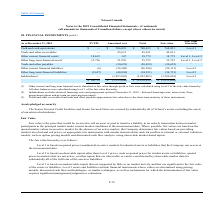From Loral Space Communications's financial document, What are the respective fair value hierarchies of cash and cash equivalents as well as other current financial liabilities? The document shows two values: Level 1 and Level 2. From the document: "current financial assets 18,632 147 18,779 18,779 Level 1, Level 2 current financial assets 18,632 147 18,779 18,779 Level 1, Level 2..." Also, What are the financial instruments classified under Level 1 under the fair value hierarchy? The document contains multiple relevant values: Cash and cash equivalents, Other current financial assets, Other long-term financial assets. From the document: "Other long-term financial assets 33,796 21,959 55,755 55,755 Level 1, Level 2 Cash and cash equivalents $ — $ 768,433 $ 768,433 $ 768,433 Level 1 Othe..." Also, What are the financial instruments that do not have a fair value hierarchy classification? The document shows two values: Trade and other receivables and Trade and other payables. From the document: "Trade and other payables — (30,659) (30,659) (30,659) Trade and other receivables — 45,631 45,631 45,631..." Also, can you calculate: What is the total fair value of financial instruments without a fair value hierarchy? Based on the calculation: 45,631 + (-30,659) , the result is 14972 (in thousands). This is based on the information: "Trade and other payables — (30,659) (30,659) (30,659) Trade and other receivables — 45,631 45,631 45,631..." The key data points involved are: 30,659, 45,631. Also, can you calculate: What is the value of the the company's cash and cash equivalents as a percentage of its total financial instruments? To answer this question, I need to perform calculations using the financial data. The calculation is: 768,433/(-3,076,851) , which equals -24.97 (percentage). This is based on the information: "Cash and cash equivalents $ — $ 768,433 $ 768,433 $ 768,433 Level 1 $ 46,795 $ (3,123,646) $ (3,076,851) $ (2,935,620)..." The key data points involved are: 3,076,851, 768,433. Also, can you calculate: What is the difference between the FVTPL of the other current and long-term financial assets? Based on the calculation: 33,796 - 18,632 , the result is 15164 (in thousands). This is based on the information: "Other current financial assets 18,632 147 18,779 18,779 Level 1, Level 2 Other long-term financial assets 33,796 21,959 55,755 55,755 Level 1, Level 2..." The key data points involved are: 18,632, 33,796. 